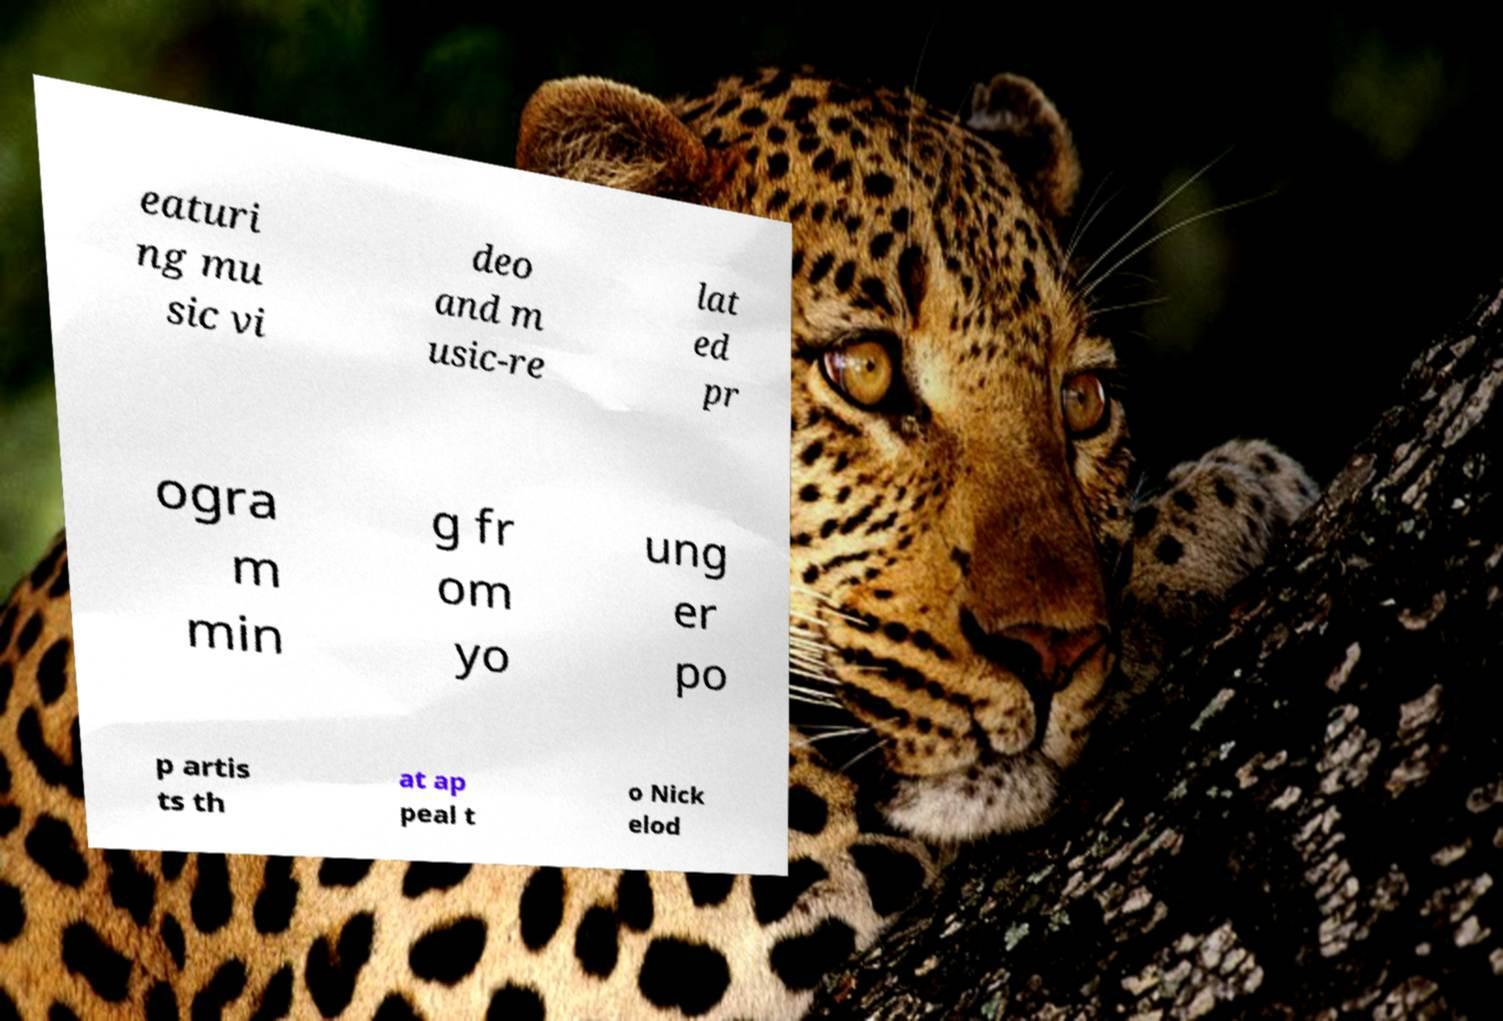There's text embedded in this image that I need extracted. Can you transcribe it verbatim? eaturi ng mu sic vi deo and m usic-re lat ed pr ogra m min g fr om yo ung er po p artis ts th at ap peal t o Nick elod 